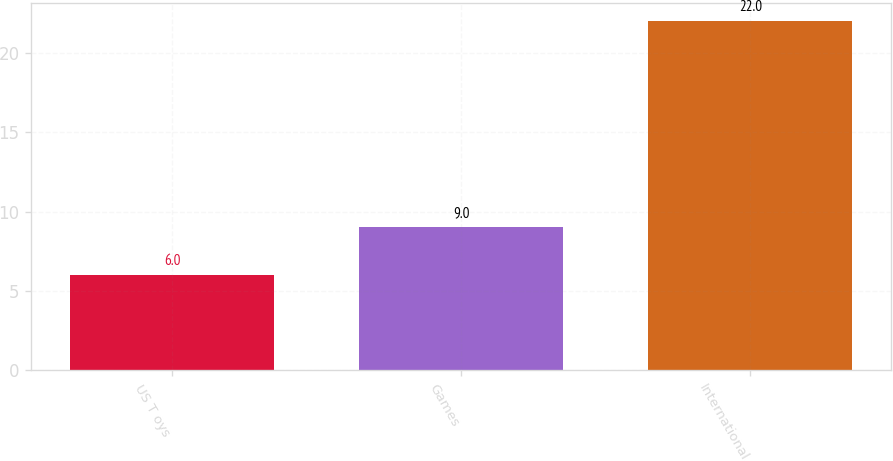Convert chart to OTSL. <chart><loc_0><loc_0><loc_500><loc_500><bar_chart><fcel>US T oys<fcel>Games<fcel>International<nl><fcel>6<fcel>9<fcel>22<nl></chart> 